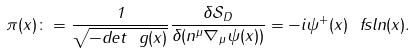<formula> <loc_0><loc_0><loc_500><loc_500>\pi ( x ) \colon = \frac { 1 } { \sqrt { - d e t \ g ( x ) } } \frac { \delta \mathcal { S } _ { D } } { \delta ( n ^ { \mu } \nabla _ { \mu } \psi ( x ) ) } = - i \psi ^ { + } ( x ) \ f s l { n } ( x ) .</formula> 